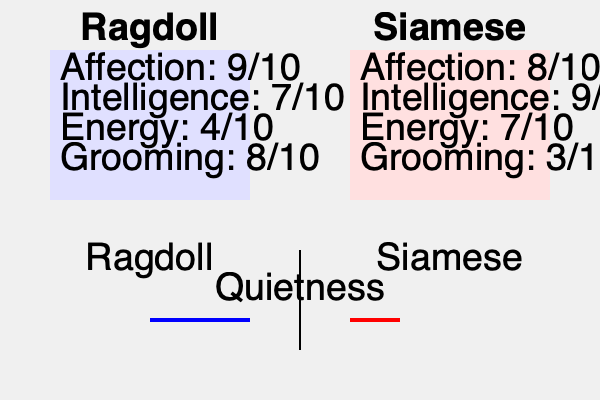Based on the comparative infographic of Ragdoll and Siamese cat breeds, which characteristic shows the most significant difference between the two breeds, and how might this impact a quiet bookkeeper's preference for a feline companion? To answer this question, we need to analyze the infographic and compare the characteristics of Ragdoll and Siamese cats:

1. Affection: Ragdoll (9/10) vs. Siamese (8/10) - Similar, slight difference
2. Intelligence: Ragdoll (7/10) vs. Siamese (9/10) - Moderate difference
3. Energy: Ragdoll (4/10) vs. Siamese (7/10) - Significant difference
4. Grooming: Ragdoll (8/10) vs. Siamese (3/10) - Largest difference
5. Quietness: Ragdoll (longer bar) vs. Siamese (shorter bar) - Significant difference

The characteristic with the most significant difference is grooming, with a 5-point difference (8/10 for Ragdoll vs. 3/10 for Siamese).

For a quiet bookkeeper who appreciates tranquility:

1. The higher grooming needs of Ragdolls might require more time and attention, which could be seen as a meditative activity for a quiet individual.
2. The quietness comparison shows Ragdolls are quieter than Siamese, aligning with the bookkeeper's preference for tranquility.
3. The lower energy level of Ragdolls (4/10) compared to Siamese (7/10) suggests a calmer companion, suitable for a quiet environment.

These factors, especially the quietness and lower energy levels, would likely make the Ragdoll a more suitable companion for a quiet bookkeeper who values tranquility, despite the higher grooming needs.
Answer: Grooming (5-point difference); Ragdoll's quieter nature and lower energy align better with a quiet bookkeeper's preference for tranquility. 